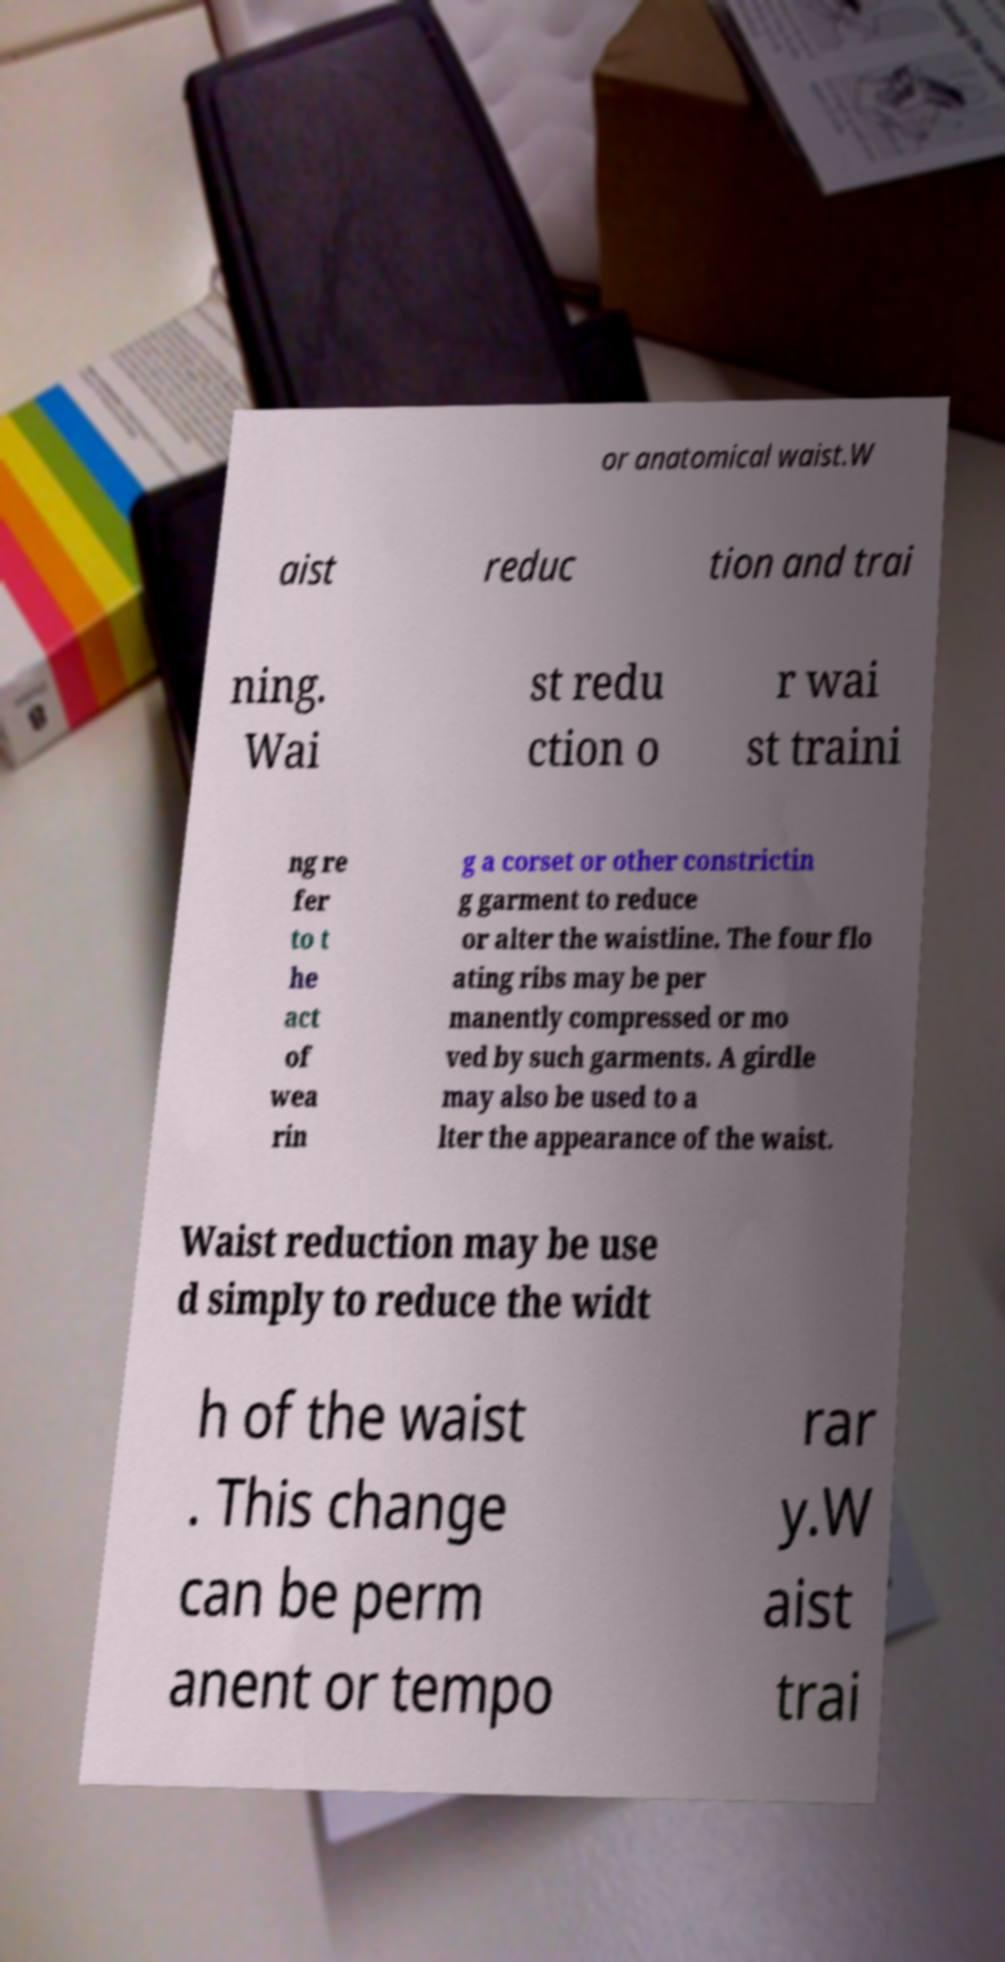Could you assist in decoding the text presented in this image and type it out clearly? or anatomical waist.W aist reduc tion and trai ning. Wai st redu ction o r wai st traini ng re fer to t he act of wea rin g a corset or other constrictin g garment to reduce or alter the waistline. The four flo ating ribs may be per manently compressed or mo ved by such garments. A girdle may also be used to a lter the appearance of the waist. Waist reduction may be use d simply to reduce the widt h of the waist . This change can be perm anent or tempo rar y.W aist trai 